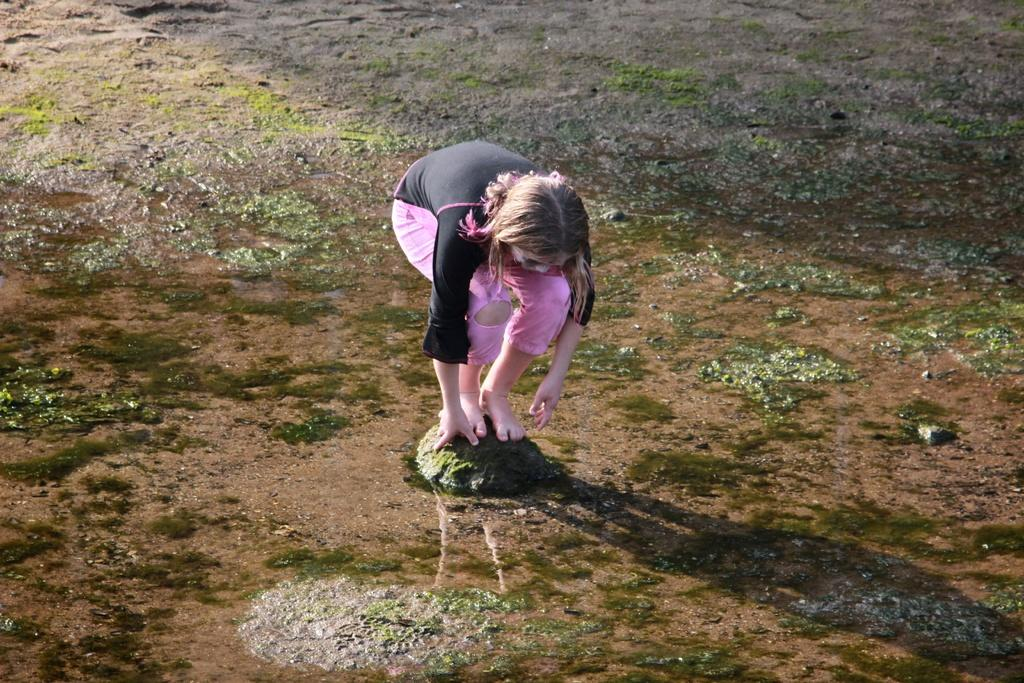Who is the main subject in the image? There is a girl in the image. What is the girl wearing? The girl is wearing a black and pink colored dress. Where is the girl standing? The girl is standing on a green rock. What can be seen in the background of the image? There is water, ground, and grass visible in the image. What type of seed is the girl planting in the image? There is no seed or planting activity present in the image. Can you describe the yak that is grazing in the background of the image? There is no yak present in the image; the background features water, ground, and grass. 